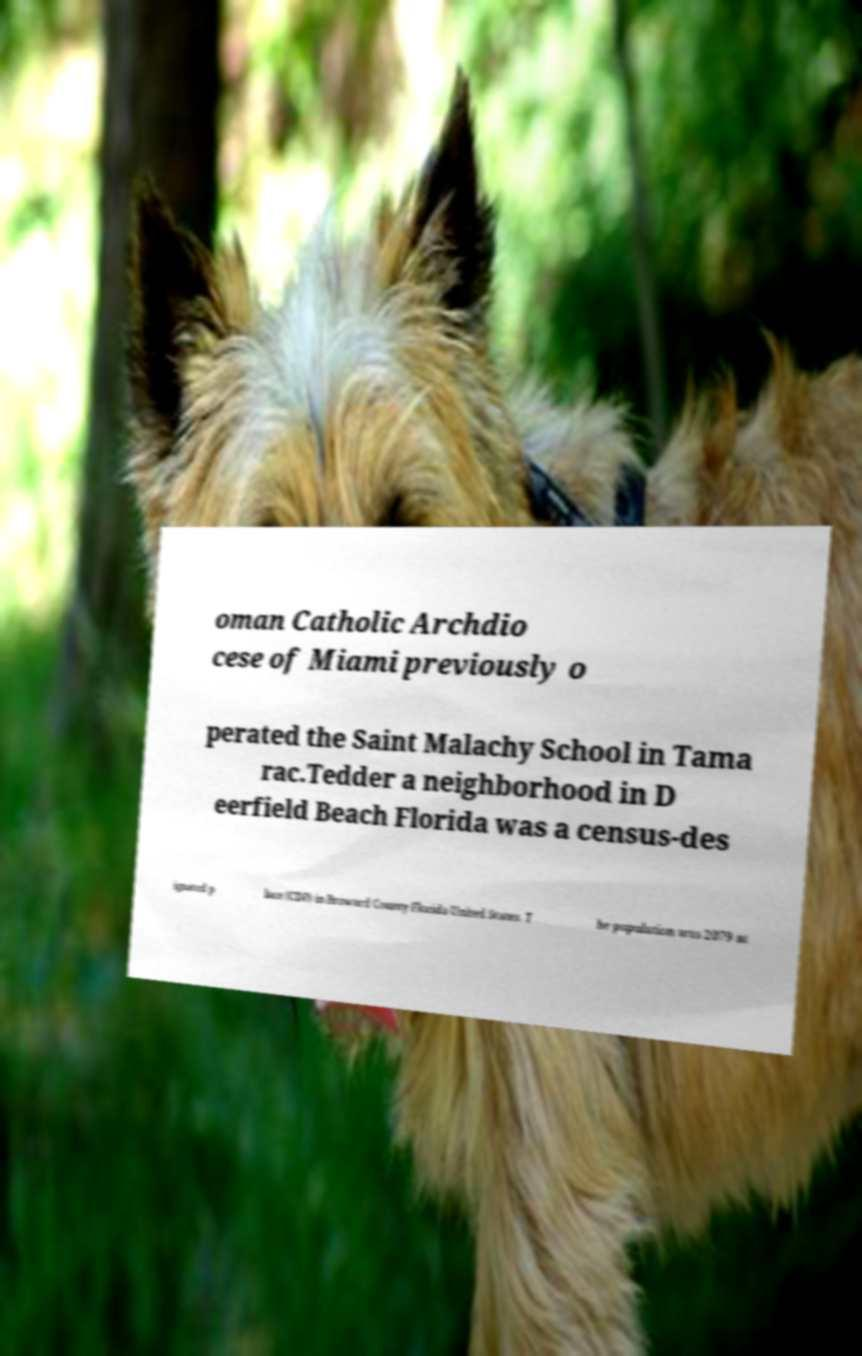Could you extract and type out the text from this image? oman Catholic Archdio cese of Miami previously o perated the Saint Malachy School in Tama rac.Tedder a neighborhood in D eerfield Beach Florida was a census-des ignated p lace (CDP) in Broward County Florida United States. T he population was 2079 at 